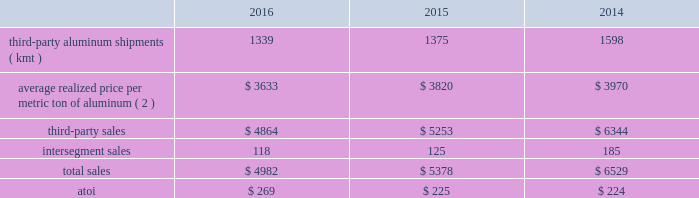Management anticipates that the effective tax rate in 2017 will be between 32% ( 32 % ) and 35% ( 35 % ) .
However , business portfolio actions , changes in the current economic environment , tax legislation or rate changes , currency fluctuations , ability to realize deferred tax assets , movements in stock price impacting tax benefits or deficiencies on stock-based payment awards , and the results of operations in certain taxing jurisdictions may cause this estimated rate to fluctuate .
Segment information arconic 2019s operations consist of three worldwide reportable segments : global rolled products , engineered products and solutions , and transportation and construction solutions ( see below ) .
Segment performance under arconic 2019s management reporting system is evaluated based on a number of factors ; however , the primary measure of performance is the after-tax operating income ( atoi ) of each segment .
Certain items such as the impact of lifo inventory accounting ; metal price lag ( the timing difference created when the average price of metal sold differs from the average cost of the metal when purchased by the respective segment 2014generally when the price of metal increases , metal lag is favorable and when the price of metal decreases , metal lag is unfavorable ) ; interest expense ; noncontrolling interests ; corporate expense ( general administrative and selling expenses of operating the corporate headquarters and other global administrative facilities , along with depreciation and amortization on corporate-owned assets ) ; restructuring and other charges ; and other items , including intersegment profit eliminations , differences between tax rates applicable to the segments and the consolidated effective tax rate , and other nonoperating items such as foreign currency transaction gains/losses and interest income are excluded from segment atoi .
Atoi for all reportable segments totaled $ 1087 in 2016 , $ 986 in 2015 , and $ 983 in 2014 .
The following information provides shipment , sales and atoi data for each reportable segment , as well as certain realized price data , for each of the three years in the period ended december 31 , 2016 .
See note o to the consolidated financial statements in part ii item 8 of this form 10-k for additional information .
Beginning in the first quarter of 2017 , arconic 2019s segment reporting metric will change from atoi to adjusted ebitda .
Global rolled products ( 1 ) .
( 1 ) excludes the warrick , in rolling operations and the equity interest in the rolling mill at the joint venture in saudi arabia , both of which were previously part of the global rolled products segment but became part of alcoa corporation effective november 1 , 2016 .
( 2 ) generally , average realized price per metric ton of aluminum includes two elements : a ) the price of metal ( the underlying base metal component based on quoted prices from the lme , plus a regional premium which represents the incremental price over the base lme component that is associated with physical delivery of metal to a particular region ) , and b ) the conversion price , which represents the incremental price over the metal price component that is associated with converting primary aluminum into sheet and plate .
In this circumstance , the metal price component is a pass-through to this segment 2019s customers with limited exception ( e.g. , fixed-priced contracts , certain regional premiums ) .
The global rolled products segment produces aluminum sheet and plate for a variety of end markets .
Sheet and plate is sold directly to customers and through distributors related to the aerospace , automotive , commercial transportation , packaging , building and construction , and industrial products ( mainly used in the production of machinery and equipment and consumer durables ) end markets .
A small portion of this segment also produces aseptic foil for the packaging end market .
While the customer base for flat-rolled products is large , a significant amount of sales of sheet .
What is the percentage of the global rolled products' atoi concerning the total atoi in 2016? 
Rationale: it is the atoi for the global rolled products divided by the atoi of all segments , then turned into a percentage .
Computations: (269 / 1087)
Answer: 0.24747. 